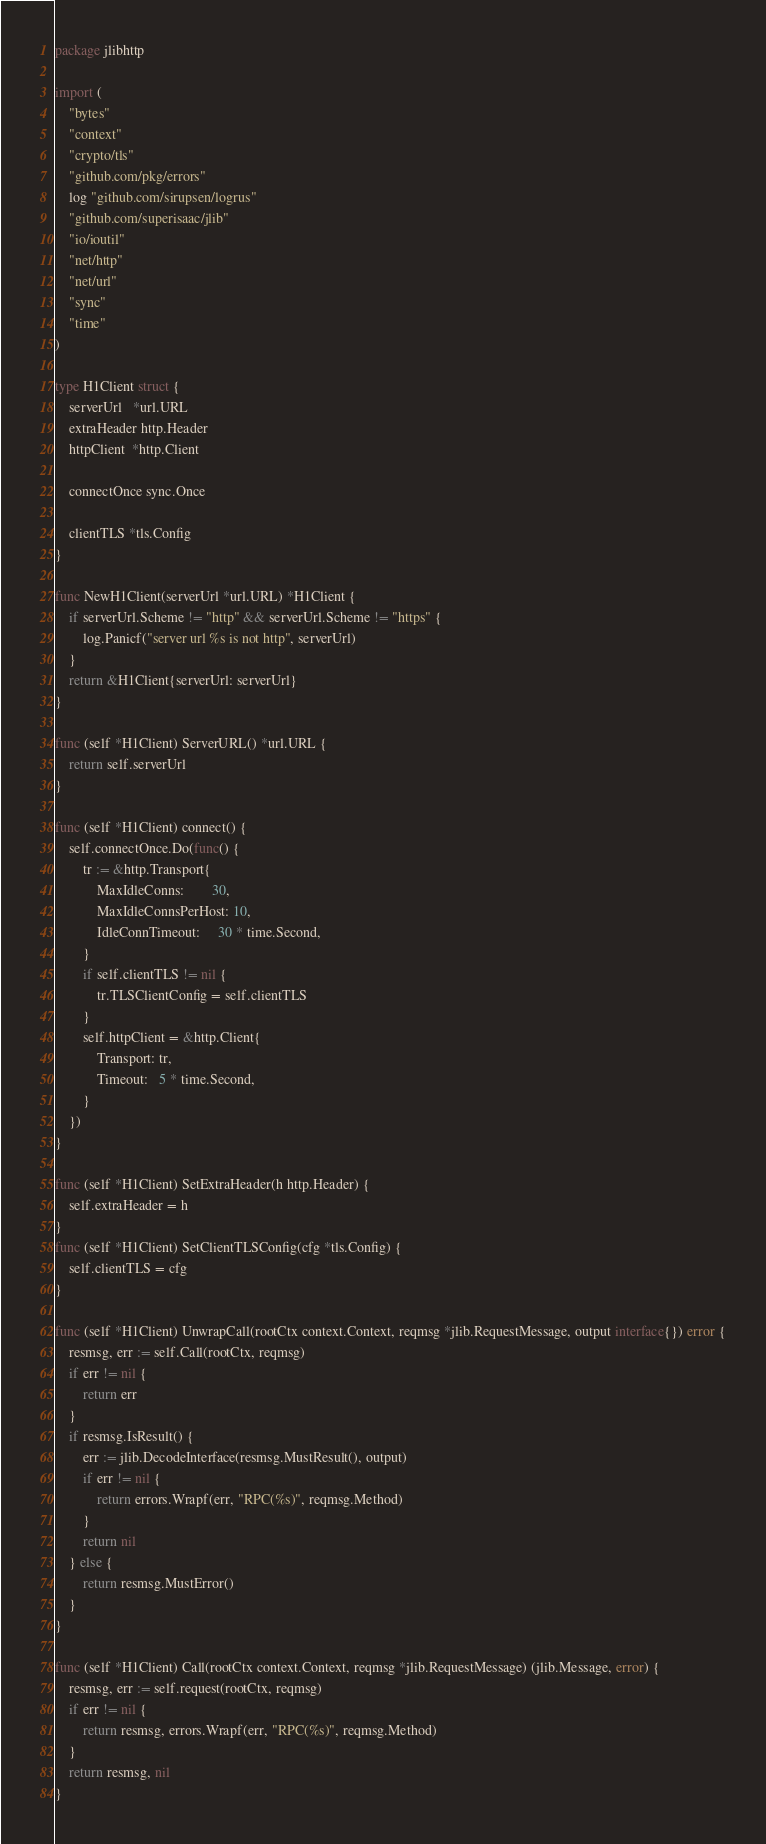Convert code to text. <code><loc_0><loc_0><loc_500><loc_500><_Go_>package jlibhttp

import (
	"bytes"
	"context"
	"crypto/tls"
	"github.com/pkg/errors"
	log "github.com/sirupsen/logrus"
	"github.com/superisaac/jlib"
	"io/ioutil"
	"net/http"
	"net/url"
	"sync"
	"time"
)

type H1Client struct {
	serverUrl   *url.URL
	extraHeader http.Header
	httpClient  *http.Client

	connectOnce sync.Once

	clientTLS *tls.Config
}

func NewH1Client(serverUrl *url.URL) *H1Client {
	if serverUrl.Scheme != "http" && serverUrl.Scheme != "https" {
		log.Panicf("server url %s is not http", serverUrl)
	}
	return &H1Client{serverUrl: serverUrl}
}

func (self *H1Client) ServerURL() *url.URL {
	return self.serverUrl
}

func (self *H1Client) connect() {
	self.connectOnce.Do(func() {
		tr := &http.Transport{
			MaxIdleConns:        30,
			MaxIdleConnsPerHost: 10,
			IdleConnTimeout:     30 * time.Second,
		}
		if self.clientTLS != nil {
			tr.TLSClientConfig = self.clientTLS
		}
		self.httpClient = &http.Client{
			Transport: tr,
			Timeout:   5 * time.Second,
		}
	})
}

func (self *H1Client) SetExtraHeader(h http.Header) {
	self.extraHeader = h
}
func (self *H1Client) SetClientTLSConfig(cfg *tls.Config) {
	self.clientTLS = cfg
}

func (self *H1Client) UnwrapCall(rootCtx context.Context, reqmsg *jlib.RequestMessage, output interface{}) error {
	resmsg, err := self.Call(rootCtx, reqmsg)
	if err != nil {
		return err
	}
	if resmsg.IsResult() {
		err := jlib.DecodeInterface(resmsg.MustResult(), output)
		if err != nil {
			return errors.Wrapf(err, "RPC(%s)", reqmsg.Method)
		}
		return nil
	} else {
		return resmsg.MustError()
	}
}

func (self *H1Client) Call(rootCtx context.Context, reqmsg *jlib.RequestMessage) (jlib.Message, error) {
	resmsg, err := self.request(rootCtx, reqmsg)
	if err != nil {
		return resmsg, errors.Wrapf(err, "RPC(%s)", reqmsg.Method)
	}
	return resmsg, nil
}
</code> 